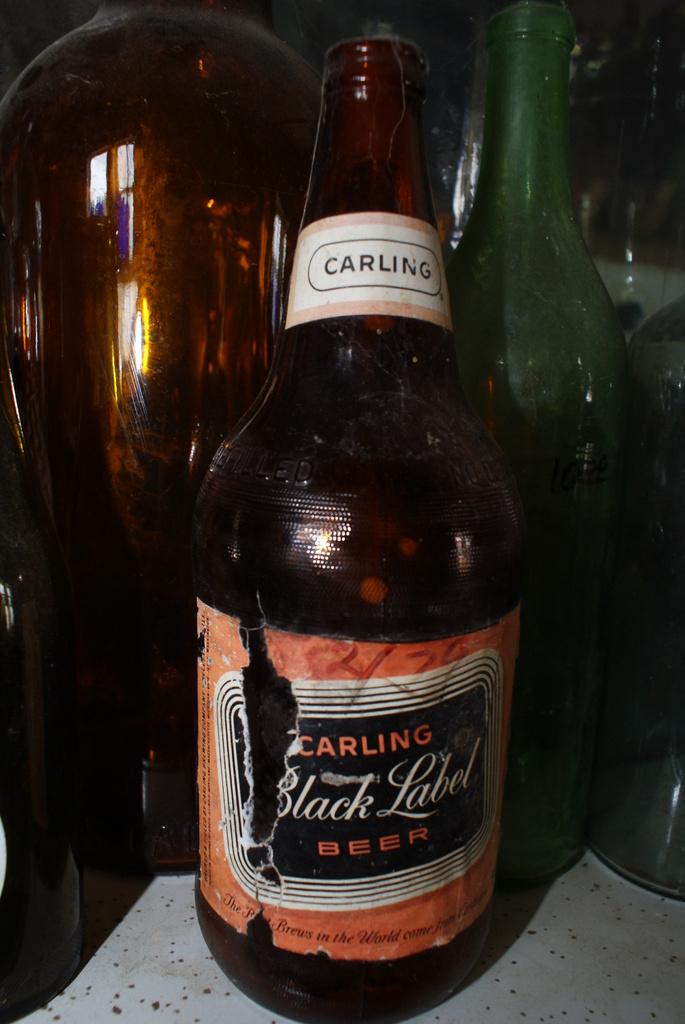What is the name of the beer?
Offer a very short reply. Carling black label. What series of carling beer is this?
Your response must be concise. Black label. 